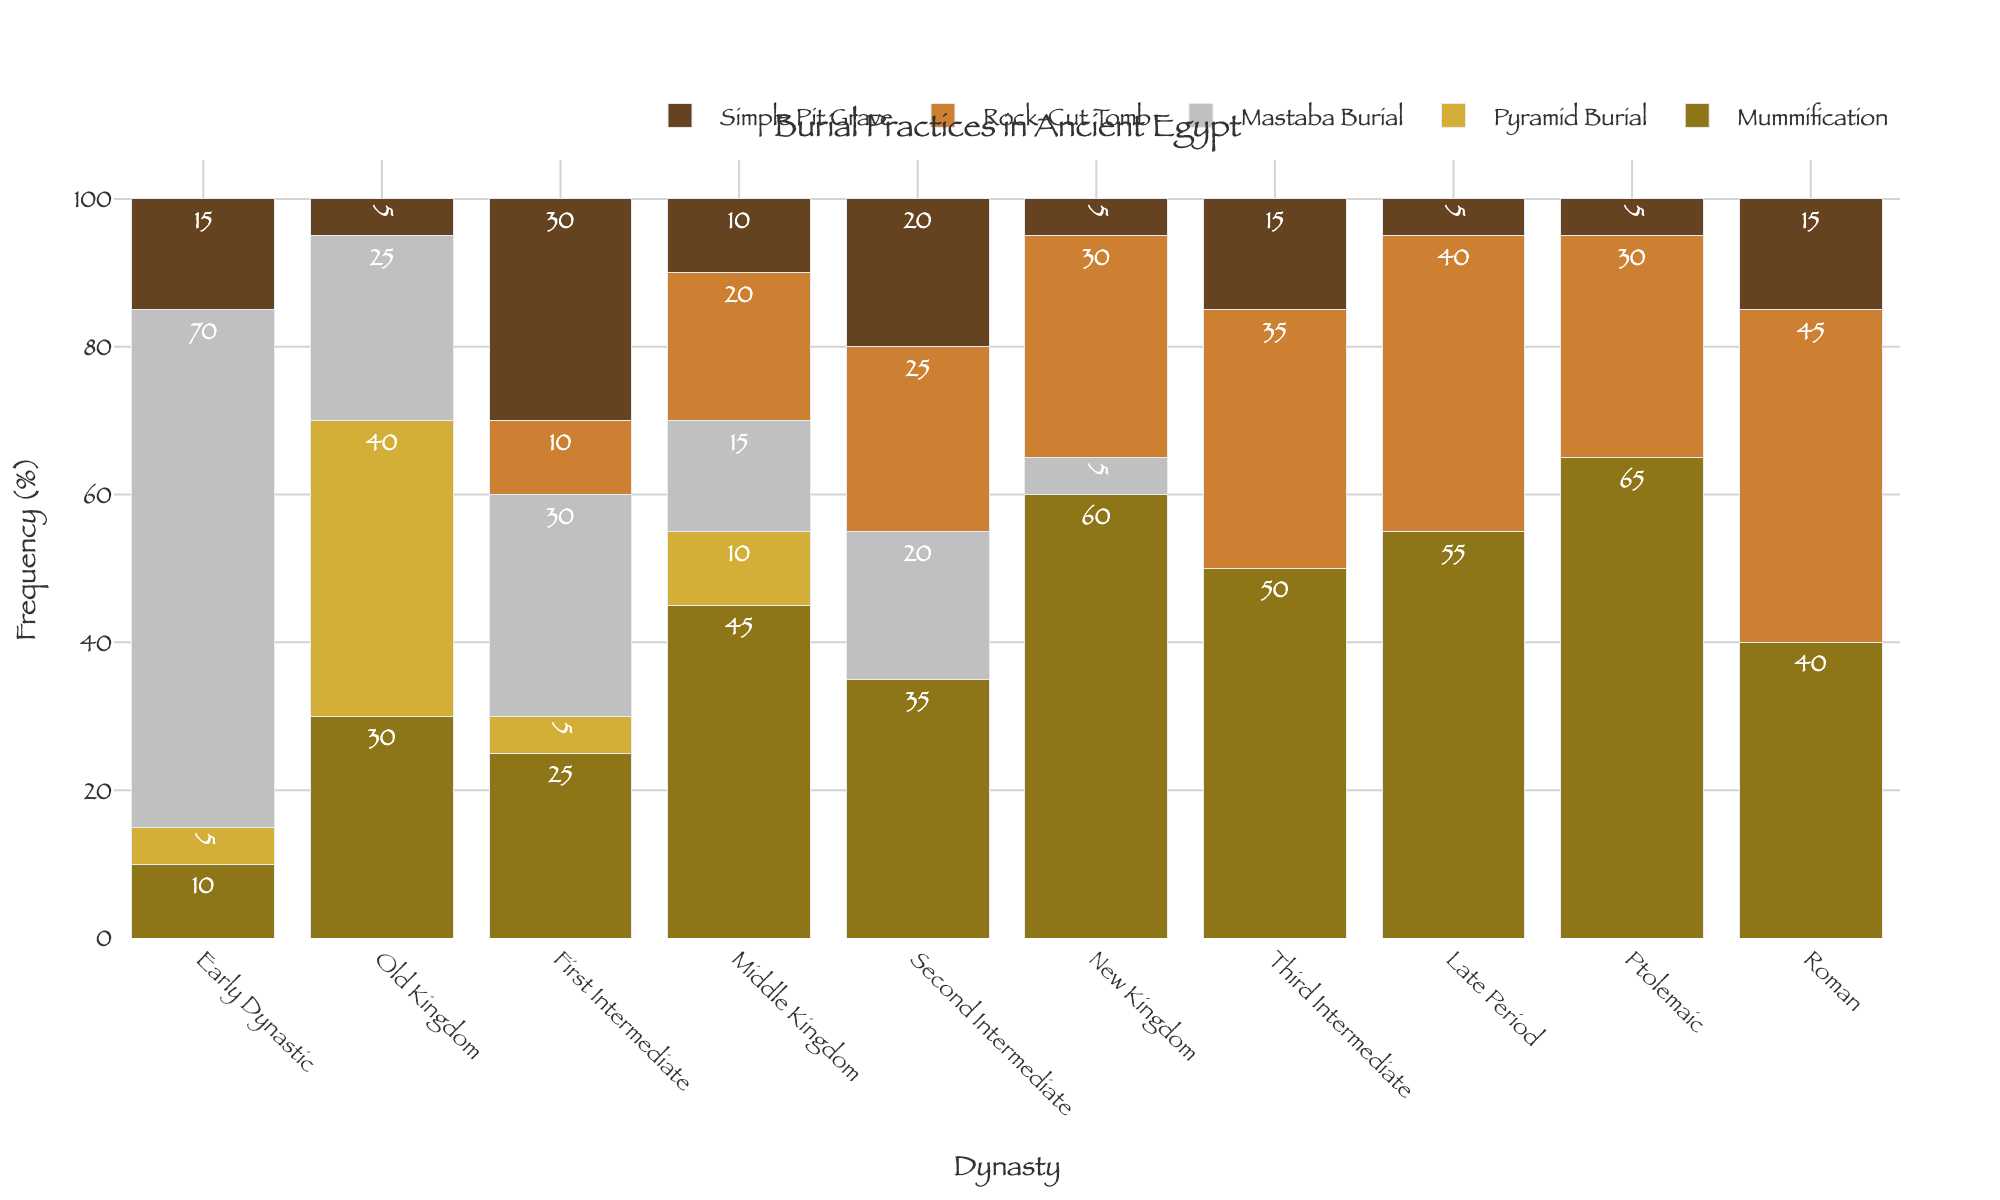Which dynasty has the highest frequency of Mummification practices? Look at the height of the bars associated with Mummification across all dynasties. The tallest bar represents the highest frequency. The New Kingdom has the highest Mummification frequency with a value of 60.
Answer: New Kingdom In terms of Pyramid Burial, how does the Old Kingdom compare to other dynasties? Refer to the bars representing Pyramid Burial in each dynasty. Only the Old Kingdom shows a significant frequency of 40, with all other dynasties showing zero.
Answer: Old Kingdom shows the highest and only significant frequency Which burial practice was most common in the Roman period? Look at the different colored segments within the Roman period bar. The tallest segment corresponds to Rock-Cut Tomb with a frequency of 45.
Answer: Rock-Cut Tomb What are the total frequencies of the different burial practices in the Middle Kingdom? Sum the heights of the individual segments in the Middle Kingdom bar across different practices: 45 (Mummification) + 10 (Pyramid Burial) + 15 (Mastaba Burial) + 20 (Rock-Cut Tomb) + 10 (Simple Pit Grave) = 100.
Answer: 100 Compare the frequency of Simple Pit Grave practices in the First and Second Intermediate periods. Which period had a higher frequency and by how much? Subtract the height of the Simple Pit Grave bar in the Second Intermediate from the First Intermediate: 30 (First Intermediate) - 20 (Second Intermediate) = 10. The First Intermediate period had a higher frequency by 10.
Answer: First Intermediate by 10 In which dynasty do we observe the most diverse burial practices based on the number of non-zero burial practices? Identify the dynasty with the highest number of non-zero practices. The First Intermediate period has 5 non-zero burial practices.
Answer: First Intermediate Which practice saw an increase in frequency from the Early Dynastic to the New Kingdom? Compare the heights of each practice from the Early Dynastic to the New Kingdom. Mummification increased from 10 to 60.
Answer: Mummification How do the burial practices of the Late Period compare to the Ptolemaic? Compare each practice one by one available in both periods. The only changes observed are: Mummification (55 vs. 65), and Rock-Cut Tomb (40 vs. 30), where Mummification increased, and Rock-Cut Tomb decreased.
Answer: Mummification increased, Rock-Cut Tomb decreased 